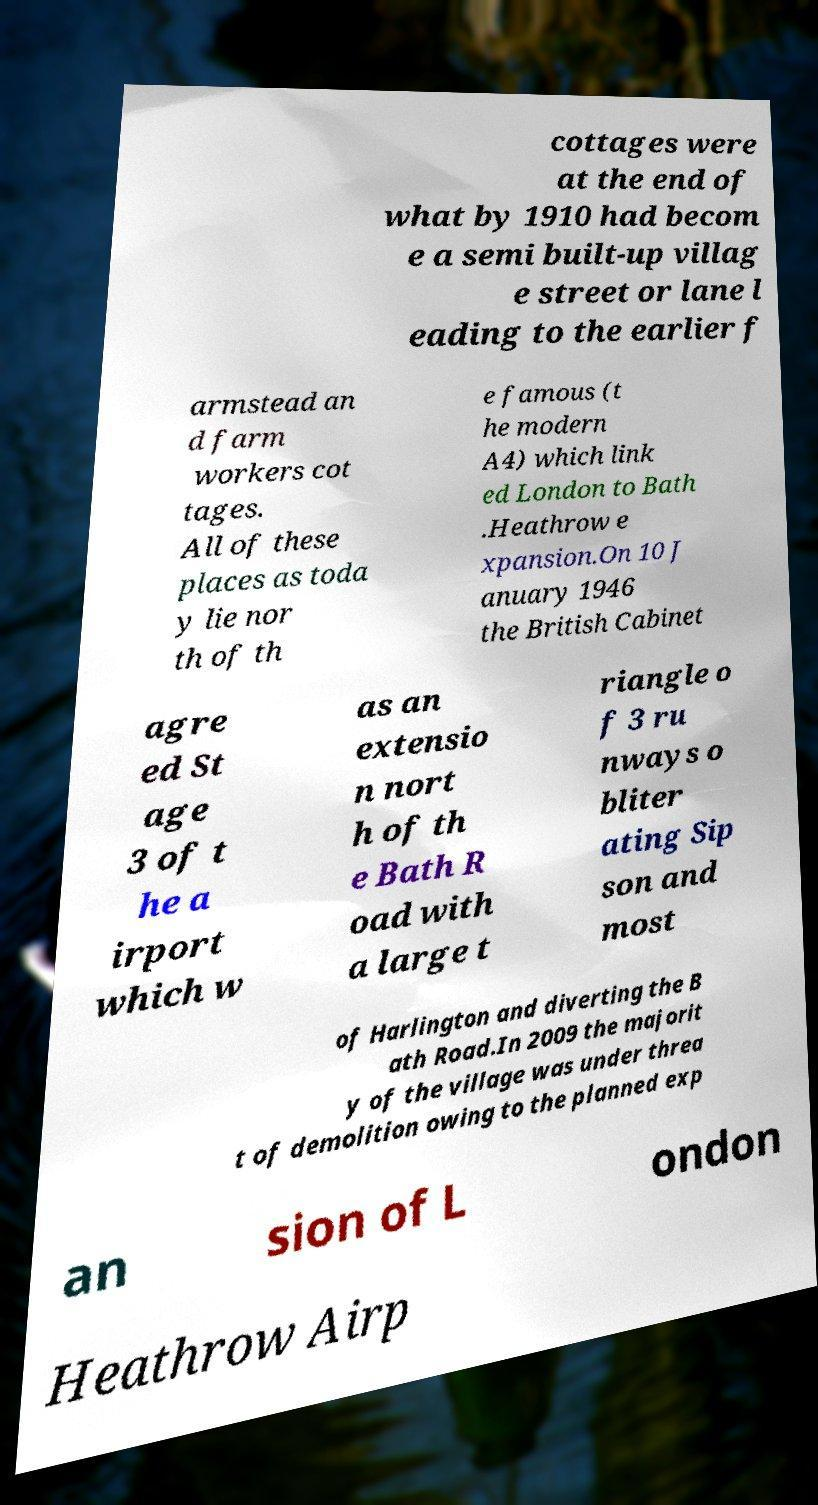For documentation purposes, I need the text within this image transcribed. Could you provide that? cottages were at the end of what by 1910 had becom e a semi built-up villag e street or lane l eading to the earlier f armstead an d farm workers cot tages. All of these places as toda y lie nor th of th e famous (t he modern A4) which link ed London to Bath .Heathrow e xpansion.On 10 J anuary 1946 the British Cabinet agre ed St age 3 of t he a irport which w as an extensio n nort h of th e Bath R oad with a large t riangle o f 3 ru nways o bliter ating Sip son and most of Harlington and diverting the B ath Road.In 2009 the majorit y of the village was under threa t of demolition owing to the planned exp an sion of L ondon Heathrow Airp 